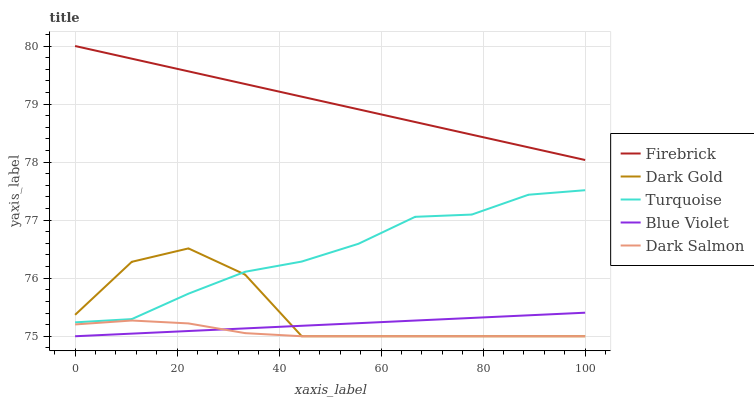Does Dark Salmon have the minimum area under the curve?
Answer yes or no. Yes. Does Firebrick have the maximum area under the curve?
Answer yes or no. Yes. Does Turquoise have the minimum area under the curve?
Answer yes or no. No. Does Turquoise have the maximum area under the curve?
Answer yes or no. No. Is Firebrick the smoothest?
Answer yes or no. Yes. Is Dark Gold the roughest?
Answer yes or no. Yes. Is Dark Salmon the smoothest?
Answer yes or no. No. Is Dark Salmon the roughest?
Answer yes or no. No. Does Turquoise have the lowest value?
Answer yes or no. No. Does Turquoise have the highest value?
Answer yes or no. No. Is Dark Gold less than Firebrick?
Answer yes or no. Yes. Is Firebrick greater than Dark Gold?
Answer yes or no. Yes. Does Dark Gold intersect Firebrick?
Answer yes or no. No. 